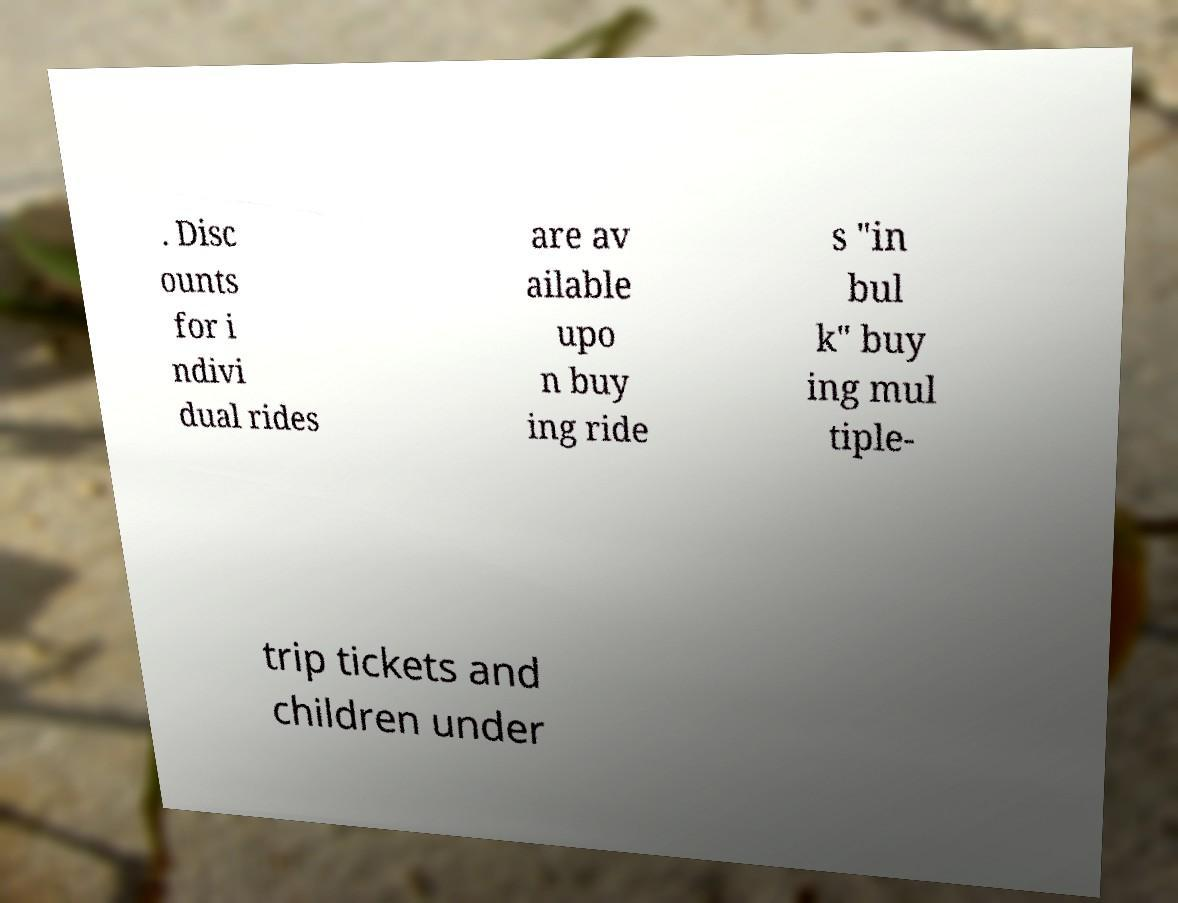What messages or text are displayed in this image? I need them in a readable, typed format. . Disc ounts for i ndivi dual rides are av ailable upo n buy ing ride s "in bul k" buy ing mul tiple- trip tickets and children under 